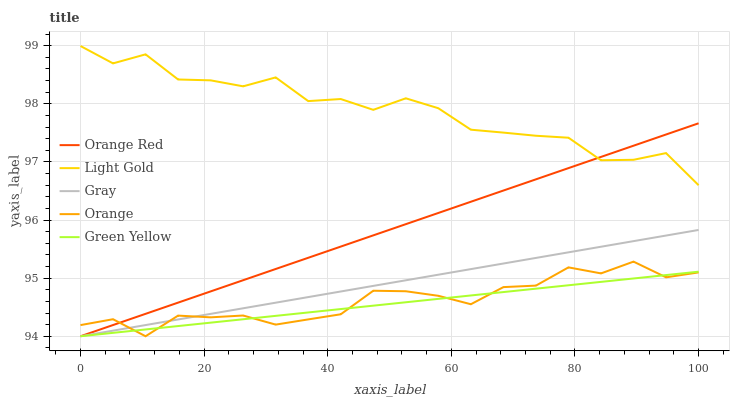Does Green Yellow have the minimum area under the curve?
Answer yes or no. Yes. Does Light Gold have the maximum area under the curve?
Answer yes or no. Yes. Does Gray have the minimum area under the curve?
Answer yes or no. No. Does Gray have the maximum area under the curve?
Answer yes or no. No. Is Gray the smoothest?
Answer yes or no. Yes. Is Light Gold the roughest?
Answer yes or no. Yes. Is Green Yellow the smoothest?
Answer yes or no. No. Is Green Yellow the roughest?
Answer yes or no. No. Does Light Gold have the lowest value?
Answer yes or no. No. Does Gray have the highest value?
Answer yes or no. No. Is Gray less than Light Gold?
Answer yes or no. Yes. Is Light Gold greater than Green Yellow?
Answer yes or no. Yes. Does Gray intersect Light Gold?
Answer yes or no. No. 